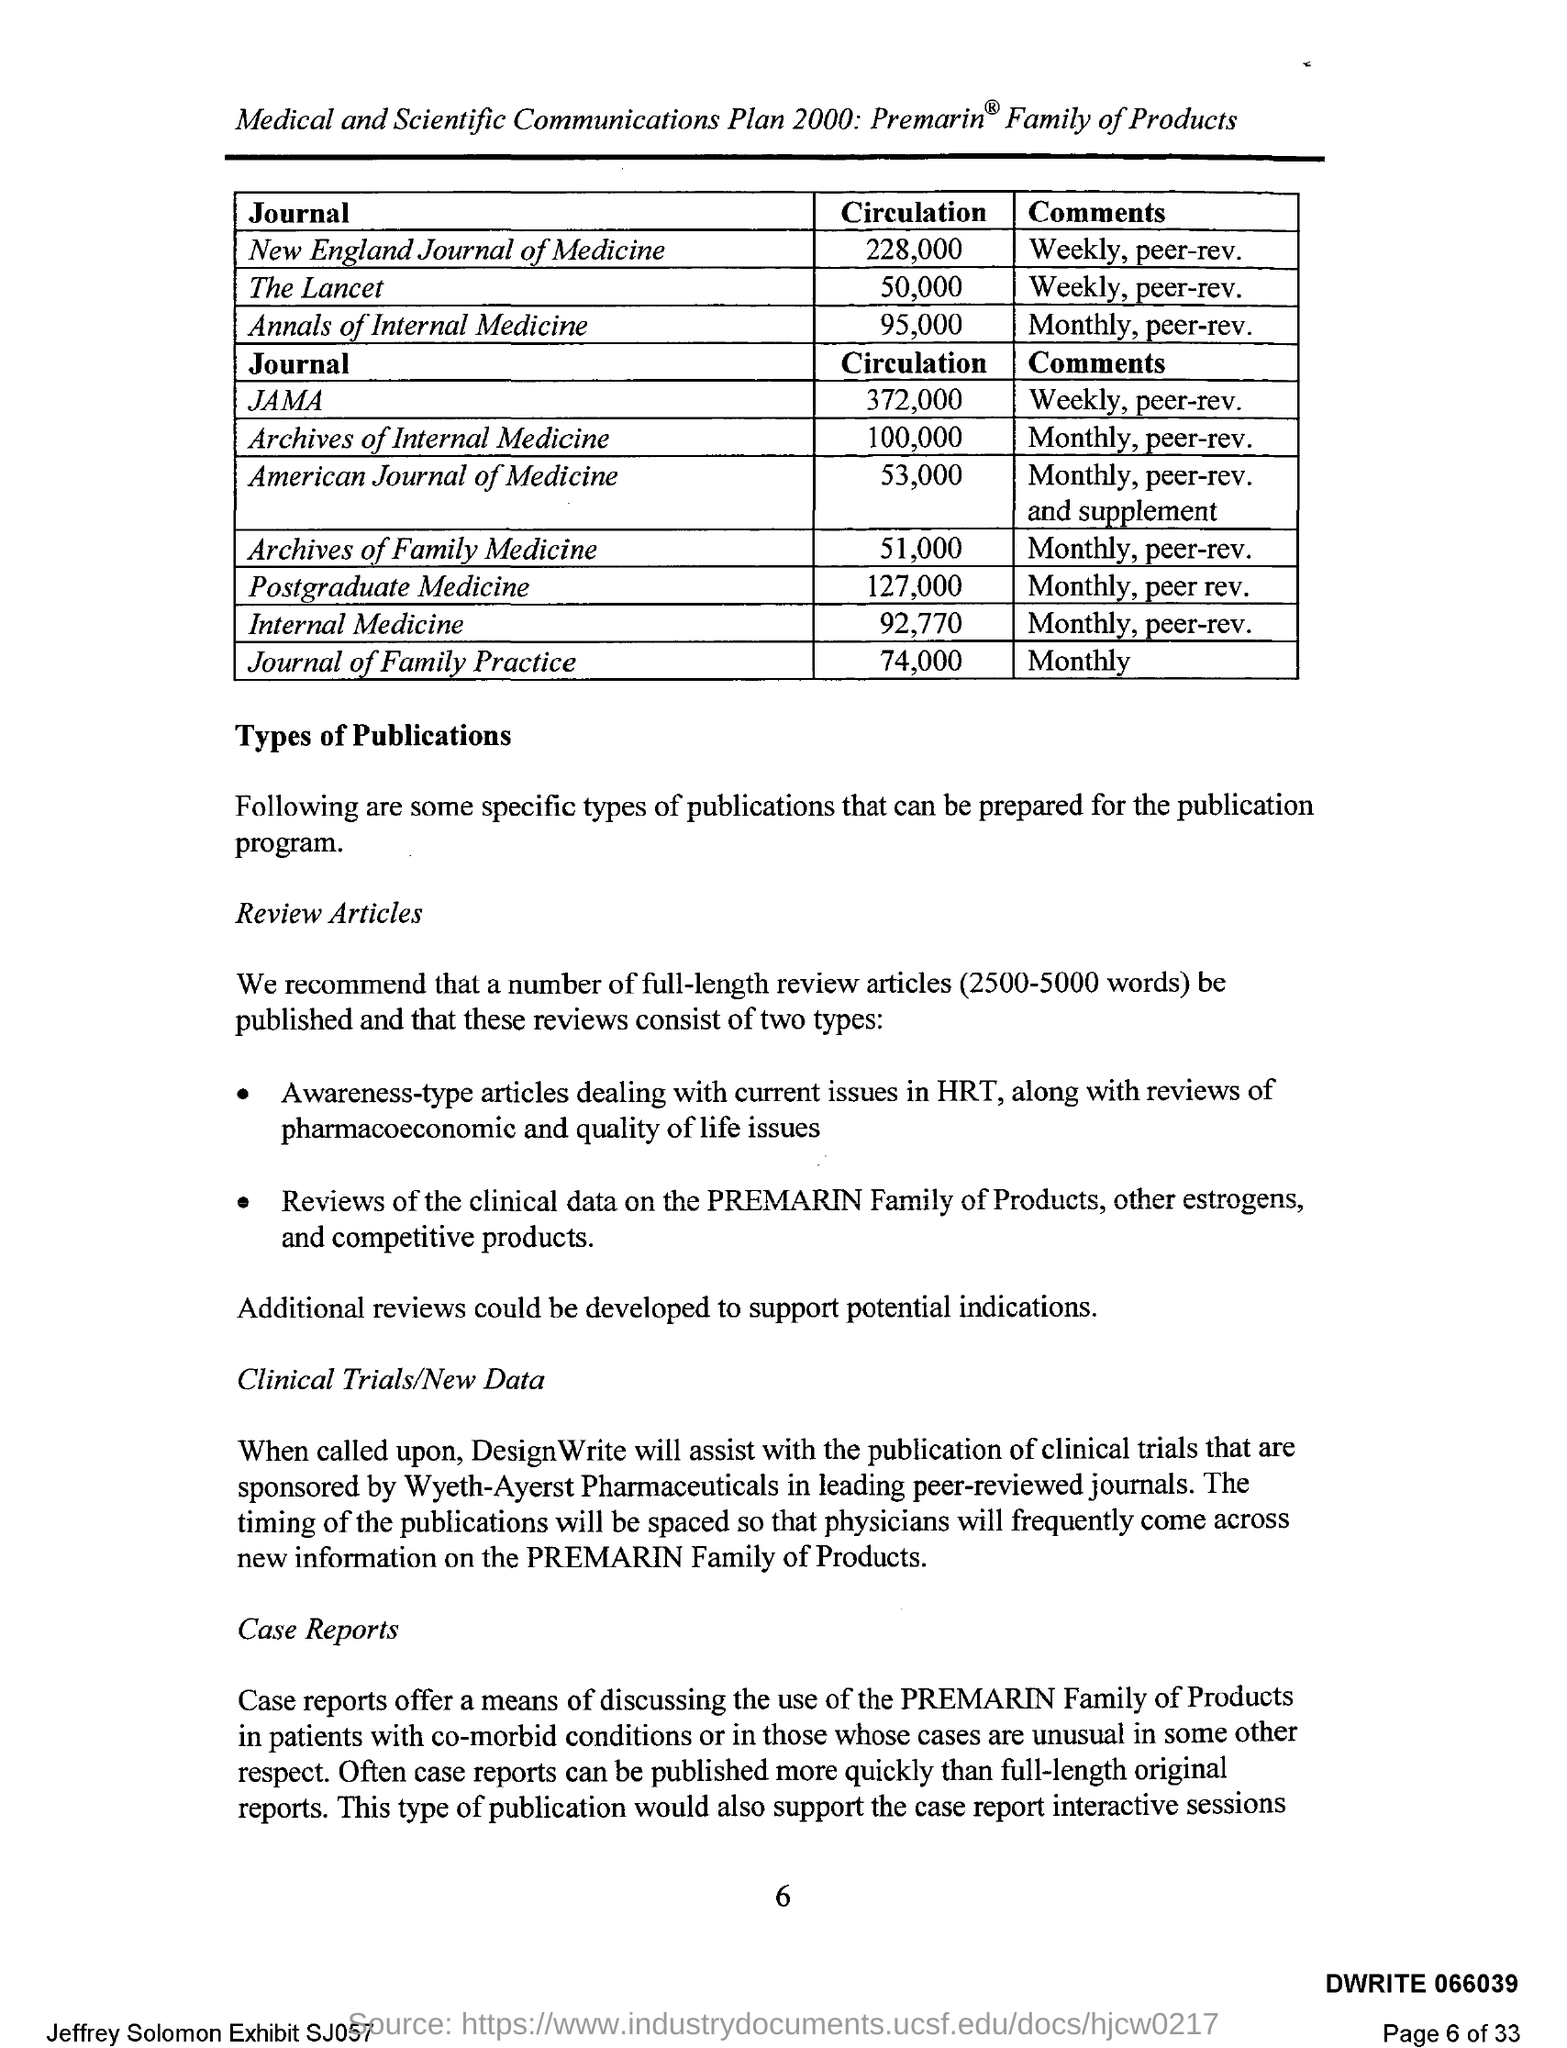Indicate a few pertinent items in this graphic. The total number of pages is 33. The Journal of Family Practice publishes its comments on a monthly basis. Circulation of the Journal of the American Medical Association is approximately 372,000. 